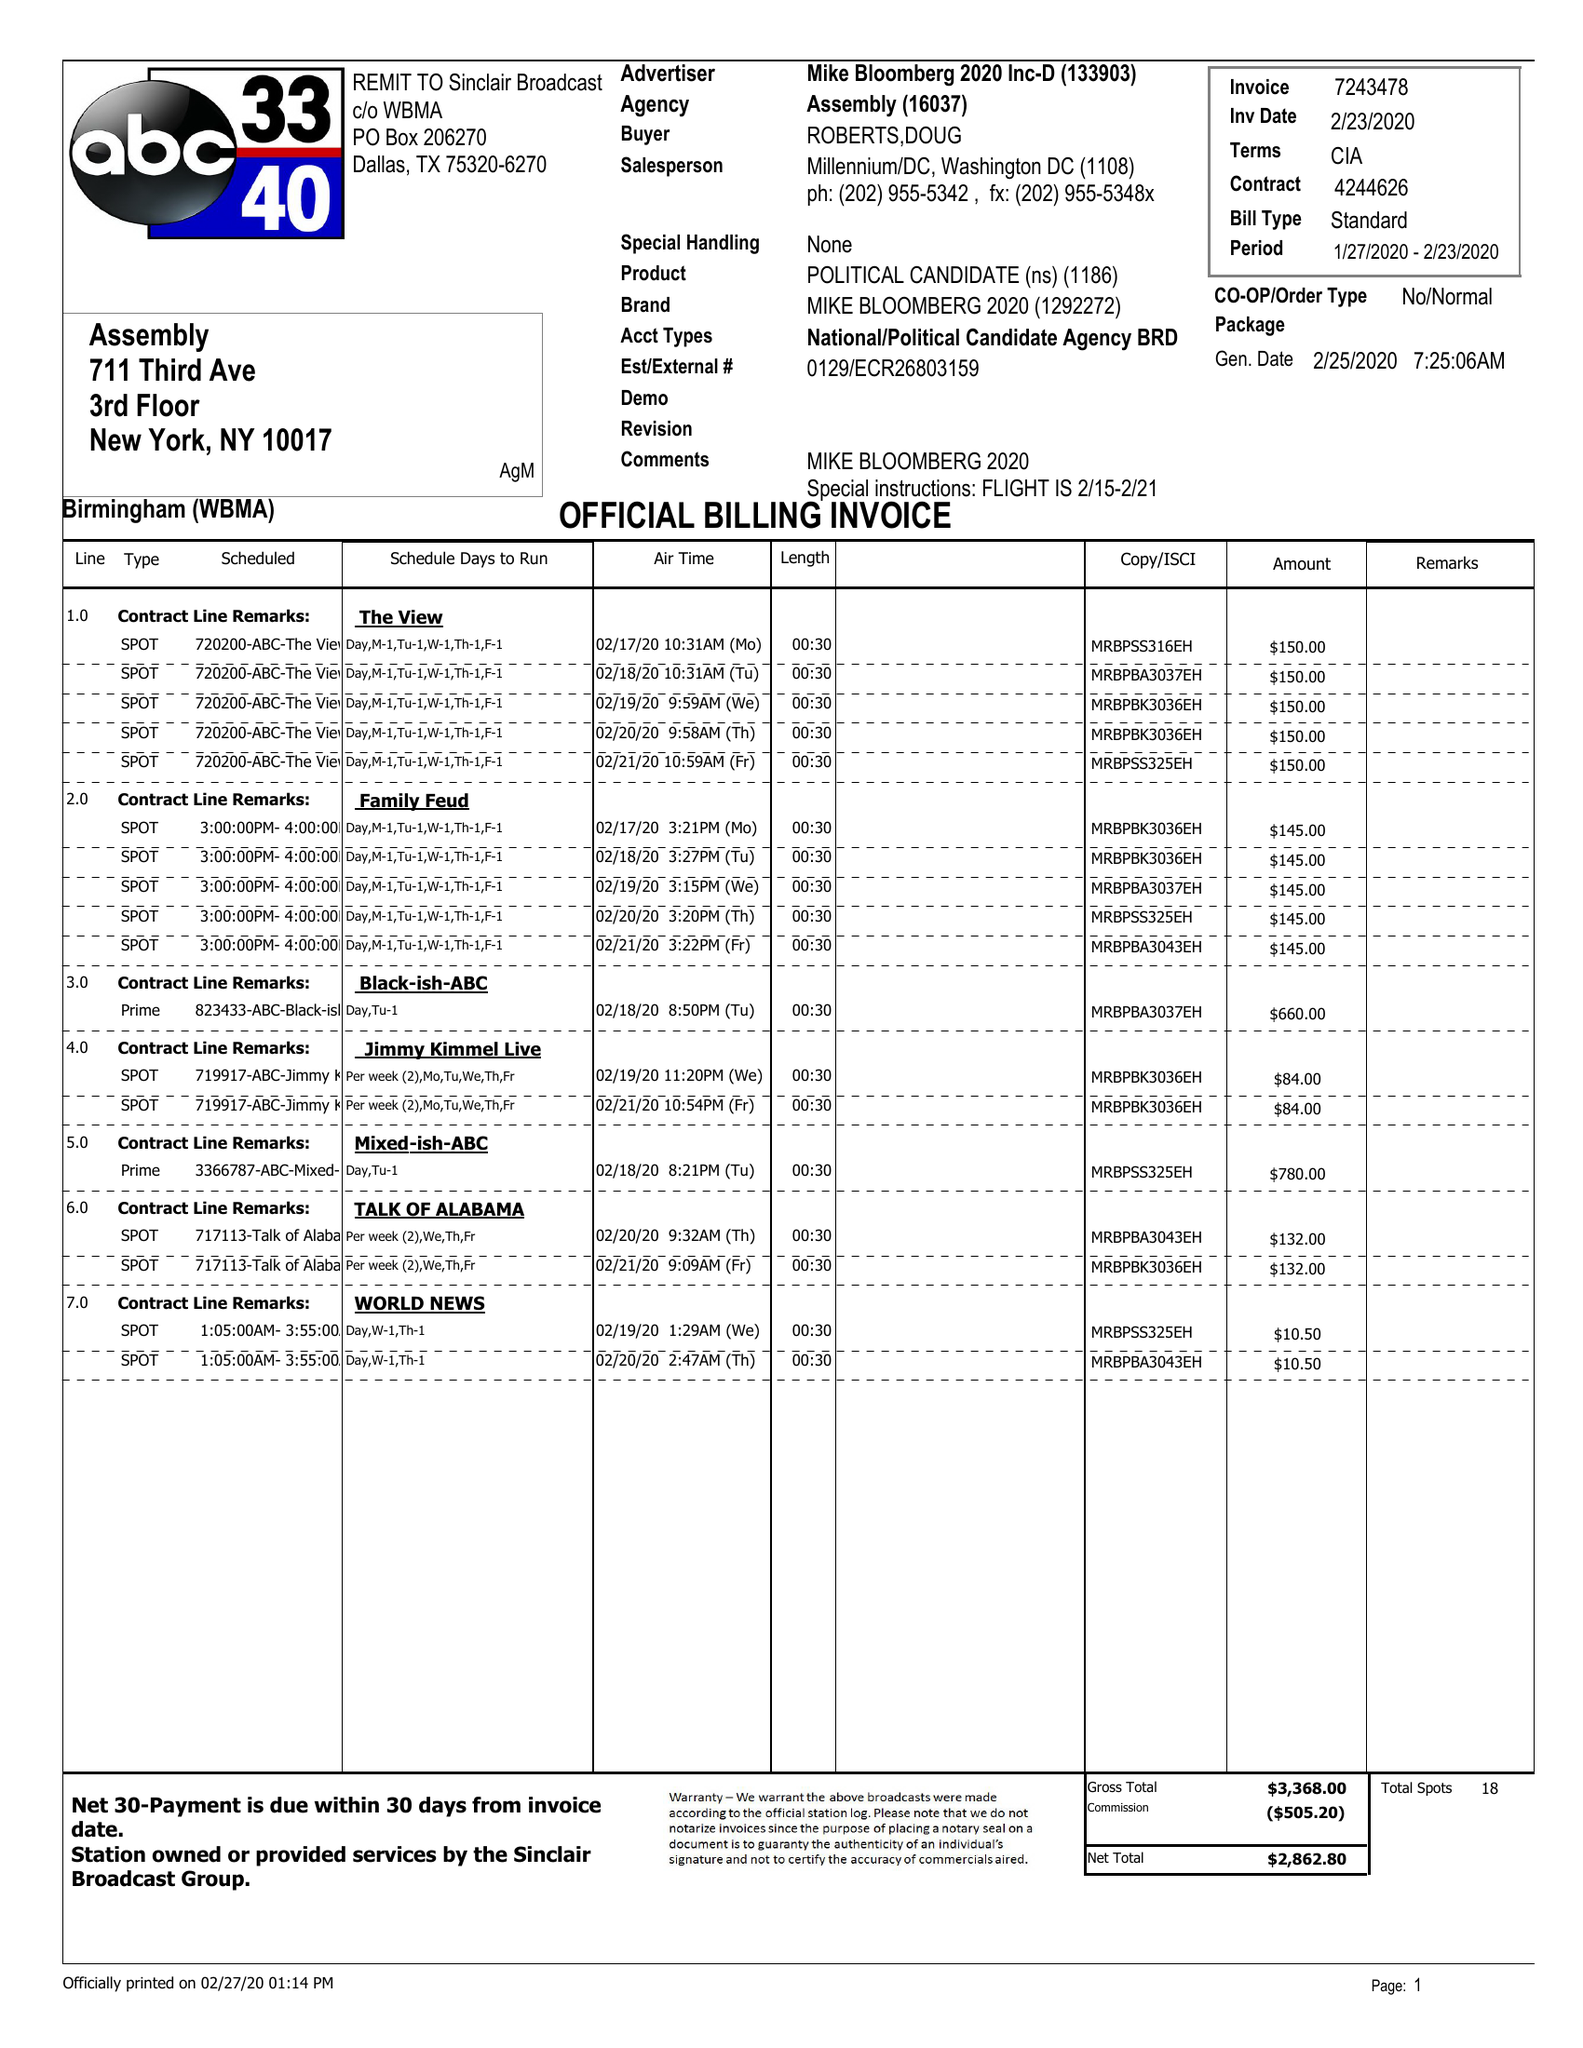What is the value for the gross_amount?
Answer the question using a single word or phrase. 3368.00 